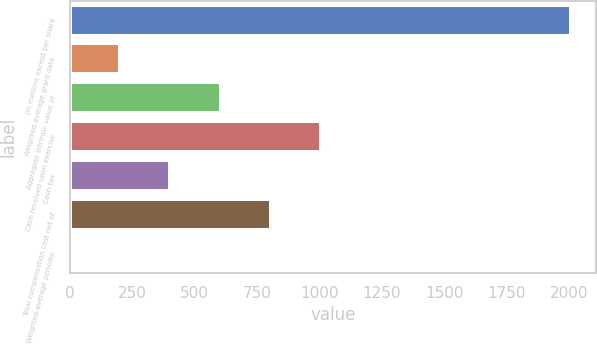<chart> <loc_0><loc_0><loc_500><loc_500><bar_chart><fcel>(in millions except per share<fcel>Weighted-average grant date<fcel>Aggregate intrinsic value of<fcel>Cash received upon exercise<fcel>Cash tax<fcel>Total compensation cost net of<fcel>Weighted-average periodin<nl><fcel>2008<fcel>202.51<fcel>603.73<fcel>1004.95<fcel>403.12<fcel>804.34<fcel>1.9<nl></chart> 